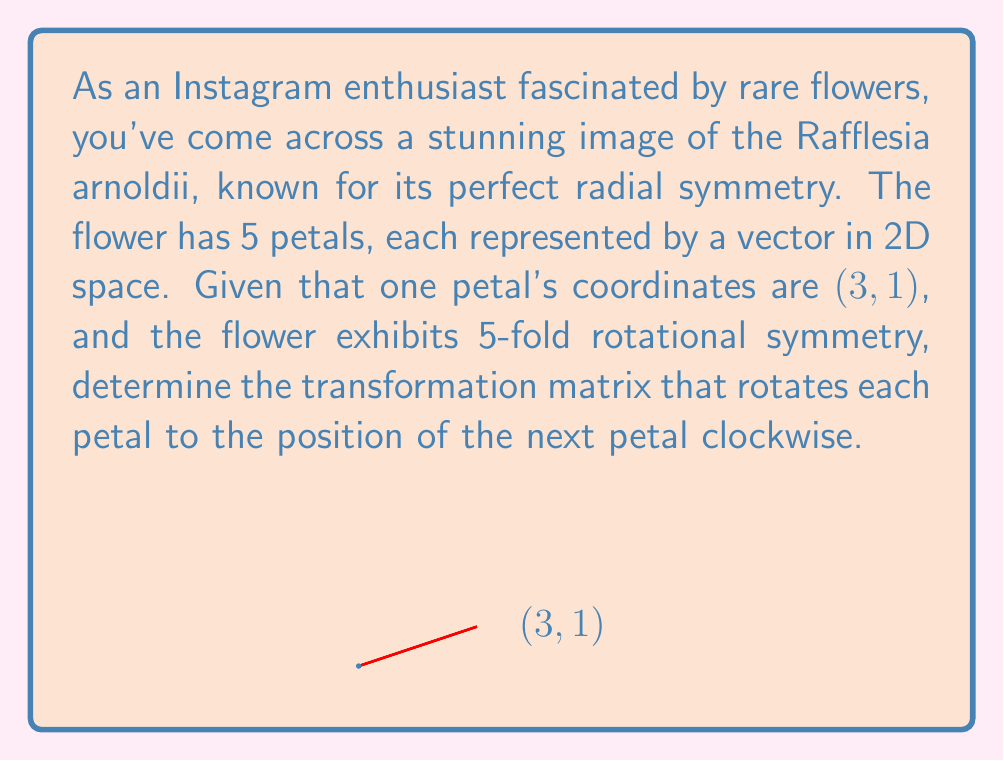Can you solve this math problem? To solve this problem, we'll follow these steps:

1) First, we need to determine the angle of rotation. For 5-fold symmetry, each rotation is 360°/5 = 72°.

2) The rotation matrix for an angle θ in 2D space is:

   $$R = \begin{bmatrix} \cos θ & -\sin θ \\ \sin θ & \cos θ \end{bmatrix}$$

3) For θ = 72°, we have:

   $$R = \begin{bmatrix} \cos 72° & -\sin 72° \\ \sin 72° & \cos 72° \end{bmatrix}$$

4) Calculate the exact values:
   $\cos 72° = \frac{\sqrt{5}+1}{4}$
   $\sin 72° = \frac{\sqrt{5(5+2\sqrt{5})}}{4}$

5) Substituting these values into the rotation matrix:

   $$R = \begin{bmatrix} 
   \frac{\sqrt{5}+1}{4} & -\frac{\sqrt{5(5+2\sqrt{5})}}{4} \\
   \frac{\sqrt{5(5+2\sqrt{5})}}{4} & \frac{\sqrt{5}+1}{4}
   \end{bmatrix}$$

This matrix R will rotate each petal vector to the position of the next petal clockwise, maintaining the flower's 5-fold rotational symmetry.
Answer: $$\begin{bmatrix} 
\frac{\sqrt{5}+1}{4} & -\frac{\sqrt{5(5+2\sqrt{5})}}{4} \\
\frac{\sqrt{5(5+2\sqrt{5})}}{4} & \frac{\sqrt{5}+1}{4}
\end{bmatrix}$$ 